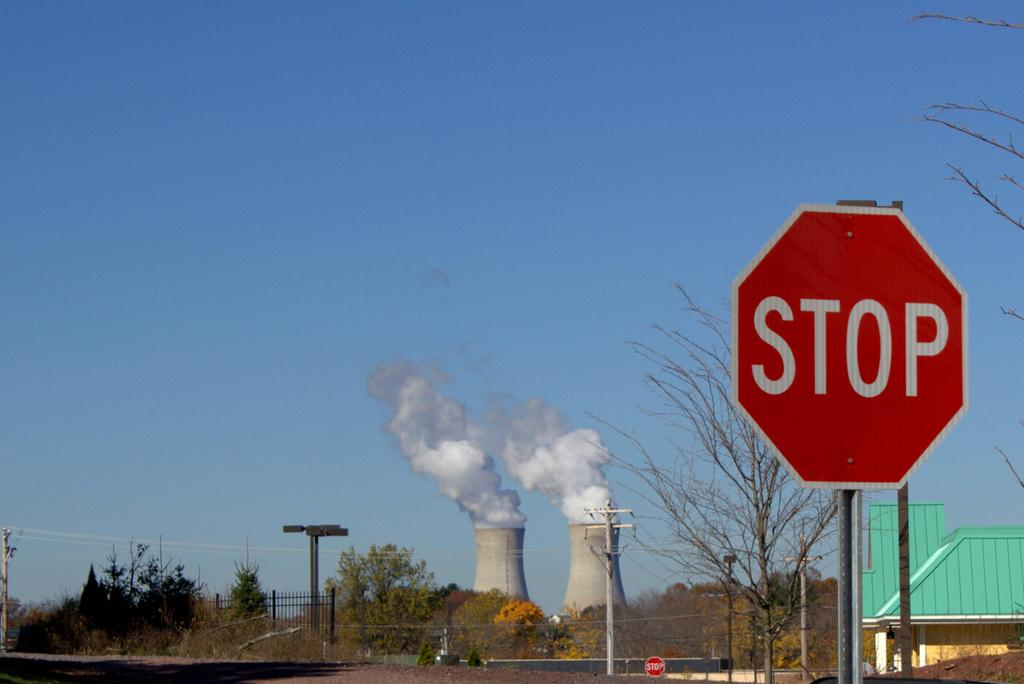<image>
Share a concise interpretation of the image provided. Nuclear reactors let off steam behind a stop sign. 